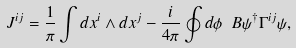Convert formula to latex. <formula><loc_0><loc_0><loc_500><loc_500>J ^ { i j } = \frac { 1 } { \pi } \int d x ^ { i } \wedge d x ^ { j } - \frac { i } { 4 \pi } \oint d \phi \ B \psi ^ { \dag } \Gamma ^ { i j } \psi ,</formula> 